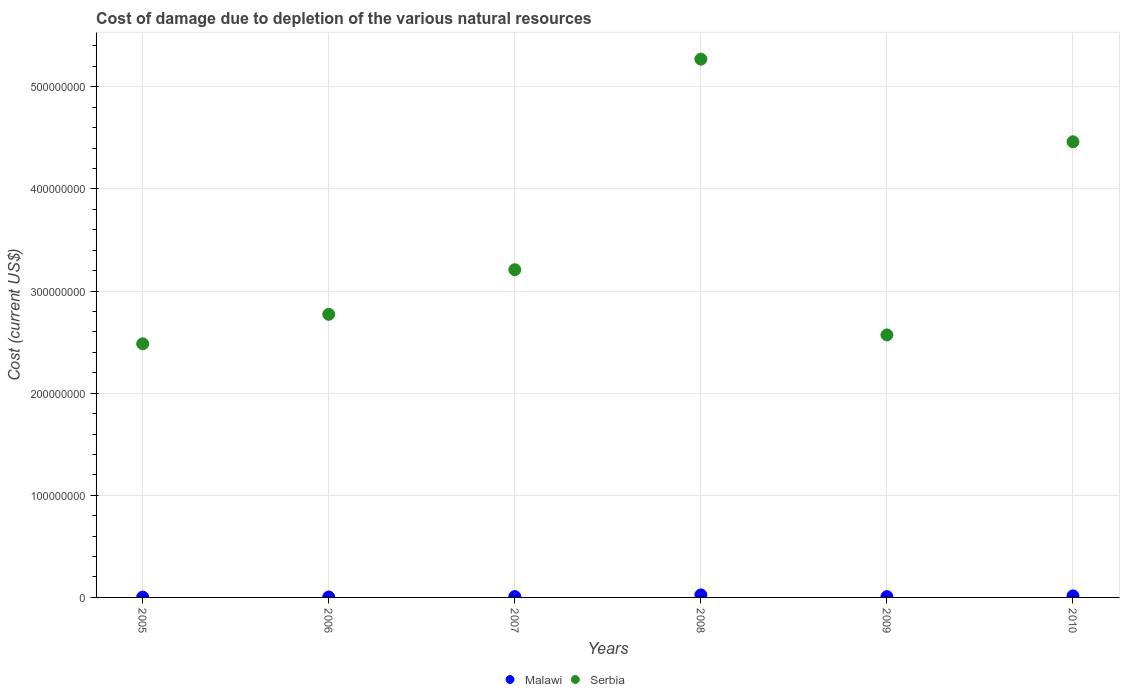Is the number of dotlines equal to the number of legend labels?
Keep it short and to the point. Yes. What is the cost of damage caused due to the depletion of various natural resources in Malawi in 2009?
Offer a terse response. 7.64e+05. Across all years, what is the maximum cost of damage caused due to the depletion of various natural resources in Malawi?
Make the answer very short. 2.45e+06. Across all years, what is the minimum cost of damage caused due to the depletion of various natural resources in Serbia?
Offer a terse response. 2.48e+08. In which year was the cost of damage caused due to the depletion of various natural resources in Serbia maximum?
Make the answer very short. 2008. What is the total cost of damage caused due to the depletion of various natural resources in Malawi in the graph?
Provide a succinct answer. 6.19e+06. What is the difference between the cost of damage caused due to the depletion of various natural resources in Malawi in 2006 and that in 2008?
Your answer should be very brief. -2.06e+06. What is the difference between the cost of damage caused due to the depletion of various natural resources in Malawi in 2005 and the cost of damage caused due to the depletion of various natural resources in Serbia in 2009?
Keep it short and to the point. -2.57e+08. What is the average cost of damage caused due to the depletion of various natural resources in Malawi per year?
Your response must be concise. 1.03e+06. In the year 2006, what is the difference between the cost of damage caused due to the depletion of various natural resources in Serbia and cost of damage caused due to the depletion of various natural resources in Malawi?
Make the answer very short. 2.77e+08. In how many years, is the cost of damage caused due to the depletion of various natural resources in Serbia greater than 440000000 US$?
Your answer should be compact. 2. What is the ratio of the cost of damage caused due to the depletion of various natural resources in Serbia in 2005 to that in 2008?
Your answer should be very brief. 0.47. Is the difference between the cost of damage caused due to the depletion of various natural resources in Serbia in 2008 and 2009 greater than the difference between the cost of damage caused due to the depletion of various natural resources in Malawi in 2008 and 2009?
Keep it short and to the point. Yes. What is the difference between the highest and the second highest cost of damage caused due to the depletion of various natural resources in Serbia?
Your answer should be compact. 8.09e+07. What is the difference between the highest and the lowest cost of damage caused due to the depletion of various natural resources in Serbia?
Your answer should be very brief. 2.79e+08. In how many years, is the cost of damage caused due to the depletion of various natural resources in Malawi greater than the average cost of damage caused due to the depletion of various natural resources in Malawi taken over all years?
Offer a terse response. 2. Is the sum of the cost of damage caused due to the depletion of various natural resources in Malawi in 2006 and 2009 greater than the maximum cost of damage caused due to the depletion of various natural resources in Serbia across all years?
Your response must be concise. No. Is the cost of damage caused due to the depletion of various natural resources in Serbia strictly greater than the cost of damage caused due to the depletion of various natural resources in Malawi over the years?
Ensure brevity in your answer.  Yes. Is the cost of damage caused due to the depletion of various natural resources in Malawi strictly less than the cost of damage caused due to the depletion of various natural resources in Serbia over the years?
Provide a succinct answer. Yes. What is the difference between two consecutive major ticks on the Y-axis?
Your response must be concise. 1.00e+08. Are the values on the major ticks of Y-axis written in scientific E-notation?
Your response must be concise. No. How many legend labels are there?
Provide a succinct answer. 2. What is the title of the graph?
Keep it short and to the point. Cost of damage due to depletion of the various natural resources. Does "Cote d'Ivoire" appear as one of the legend labels in the graph?
Offer a very short reply. No. What is the label or title of the Y-axis?
Your response must be concise. Cost (current US$). What is the Cost (current US$) of Malawi in 2005?
Keep it short and to the point. 2.70e+05. What is the Cost (current US$) in Serbia in 2005?
Offer a very short reply. 2.48e+08. What is the Cost (current US$) in Malawi in 2006?
Make the answer very short. 3.92e+05. What is the Cost (current US$) in Serbia in 2006?
Make the answer very short. 2.77e+08. What is the Cost (current US$) in Malawi in 2007?
Provide a succinct answer. 8.16e+05. What is the Cost (current US$) of Serbia in 2007?
Offer a terse response. 3.21e+08. What is the Cost (current US$) of Malawi in 2008?
Your response must be concise. 2.45e+06. What is the Cost (current US$) of Serbia in 2008?
Offer a very short reply. 5.27e+08. What is the Cost (current US$) in Malawi in 2009?
Offer a very short reply. 7.64e+05. What is the Cost (current US$) in Serbia in 2009?
Offer a terse response. 2.57e+08. What is the Cost (current US$) in Malawi in 2010?
Provide a succinct answer. 1.50e+06. What is the Cost (current US$) of Serbia in 2010?
Offer a terse response. 4.46e+08. Across all years, what is the maximum Cost (current US$) of Malawi?
Make the answer very short. 2.45e+06. Across all years, what is the maximum Cost (current US$) in Serbia?
Offer a very short reply. 5.27e+08. Across all years, what is the minimum Cost (current US$) of Malawi?
Provide a succinct answer. 2.70e+05. Across all years, what is the minimum Cost (current US$) in Serbia?
Your response must be concise. 2.48e+08. What is the total Cost (current US$) in Malawi in the graph?
Keep it short and to the point. 6.19e+06. What is the total Cost (current US$) in Serbia in the graph?
Ensure brevity in your answer.  2.08e+09. What is the difference between the Cost (current US$) of Malawi in 2005 and that in 2006?
Give a very brief answer. -1.23e+05. What is the difference between the Cost (current US$) in Serbia in 2005 and that in 2006?
Provide a short and direct response. -2.89e+07. What is the difference between the Cost (current US$) of Malawi in 2005 and that in 2007?
Keep it short and to the point. -5.46e+05. What is the difference between the Cost (current US$) of Serbia in 2005 and that in 2007?
Offer a very short reply. -7.25e+07. What is the difference between the Cost (current US$) in Malawi in 2005 and that in 2008?
Provide a short and direct response. -2.18e+06. What is the difference between the Cost (current US$) in Serbia in 2005 and that in 2008?
Offer a terse response. -2.79e+08. What is the difference between the Cost (current US$) of Malawi in 2005 and that in 2009?
Your answer should be very brief. -4.94e+05. What is the difference between the Cost (current US$) of Serbia in 2005 and that in 2009?
Provide a succinct answer. -8.68e+06. What is the difference between the Cost (current US$) of Malawi in 2005 and that in 2010?
Offer a terse response. -1.23e+06. What is the difference between the Cost (current US$) of Serbia in 2005 and that in 2010?
Give a very brief answer. -1.98e+08. What is the difference between the Cost (current US$) of Malawi in 2006 and that in 2007?
Your answer should be very brief. -4.23e+05. What is the difference between the Cost (current US$) in Serbia in 2006 and that in 2007?
Provide a short and direct response. -4.37e+07. What is the difference between the Cost (current US$) of Malawi in 2006 and that in 2008?
Offer a very short reply. -2.06e+06. What is the difference between the Cost (current US$) of Serbia in 2006 and that in 2008?
Offer a terse response. -2.50e+08. What is the difference between the Cost (current US$) of Malawi in 2006 and that in 2009?
Offer a very short reply. -3.72e+05. What is the difference between the Cost (current US$) in Serbia in 2006 and that in 2009?
Provide a succinct answer. 2.02e+07. What is the difference between the Cost (current US$) in Malawi in 2006 and that in 2010?
Keep it short and to the point. -1.10e+06. What is the difference between the Cost (current US$) of Serbia in 2006 and that in 2010?
Ensure brevity in your answer.  -1.69e+08. What is the difference between the Cost (current US$) in Malawi in 2007 and that in 2008?
Ensure brevity in your answer.  -1.63e+06. What is the difference between the Cost (current US$) of Serbia in 2007 and that in 2008?
Your answer should be compact. -2.06e+08. What is the difference between the Cost (current US$) of Malawi in 2007 and that in 2009?
Give a very brief answer. 5.16e+04. What is the difference between the Cost (current US$) in Serbia in 2007 and that in 2009?
Make the answer very short. 6.39e+07. What is the difference between the Cost (current US$) of Malawi in 2007 and that in 2010?
Provide a succinct answer. -6.81e+05. What is the difference between the Cost (current US$) of Serbia in 2007 and that in 2010?
Your response must be concise. -1.25e+08. What is the difference between the Cost (current US$) in Malawi in 2008 and that in 2009?
Offer a terse response. 1.69e+06. What is the difference between the Cost (current US$) in Serbia in 2008 and that in 2009?
Your answer should be compact. 2.70e+08. What is the difference between the Cost (current US$) in Malawi in 2008 and that in 2010?
Your answer should be very brief. 9.53e+05. What is the difference between the Cost (current US$) of Serbia in 2008 and that in 2010?
Make the answer very short. 8.09e+07. What is the difference between the Cost (current US$) of Malawi in 2009 and that in 2010?
Ensure brevity in your answer.  -7.32e+05. What is the difference between the Cost (current US$) of Serbia in 2009 and that in 2010?
Provide a succinct answer. -1.89e+08. What is the difference between the Cost (current US$) of Malawi in 2005 and the Cost (current US$) of Serbia in 2006?
Keep it short and to the point. -2.77e+08. What is the difference between the Cost (current US$) of Malawi in 2005 and the Cost (current US$) of Serbia in 2007?
Ensure brevity in your answer.  -3.21e+08. What is the difference between the Cost (current US$) of Malawi in 2005 and the Cost (current US$) of Serbia in 2008?
Provide a short and direct response. -5.27e+08. What is the difference between the Cost (current US$) of Malawi in 2005 and the Cost (current US$) of Serbia in 2009?
Your answer should be very brief. -2.57e+08. What is the difference between the Cost (current US$) in Malawi in 2005 and the Cost (current US$) in Serbia in 2010?
Provide a short and direct response. -4.46e+08. What is the difference between the Cost (current US$) of Malawi in 2006 and the Cost (current US$) of Serbia in 2007?
Your answer should be very brief. -3.20e+08. What is the difference between the Cost (current US$) of Malawi in 2006 and the Cost (current US$) of Serbia in 2008?
Offer a very short reply. -5.27e+08. What is the difference between the Cost (current US$) of Malawi in 2006 and the Cost (current US$) of Serbia in 2009?
Your answer should be very brief. -2.57e+08. What is the difference between the Cost (current US$) of Malawi in 2006 and the Cost (current US$) of Serbia in 2010?
Offer a terse response. -4.46e+08. What is the difference between the Cost (current US$) of Malawi in 2007 and the Cost (current US$) of Serbia in 2008?
Keep it short and to the point. -5.26e+08. What is the difference between the Cost (current US$) in Malawi in 2007 and the Cost (current US$) in Serbia in 2009?
Your answer should be compact. -2.56e+08. What is the difference between the Cost (current US$) in Malawi in 2007 and the Cost (current US$) in Serbia in 2010?
Offer a very short reply. -4.45e+08. What is the difference between the Cost (current US$) of Malawi in 2008 and the Cost (current US$) of Serbia in 2009?
Ensure brevity in your answer.  -2.55e+08. What is the difference between the Cost (current US$) in Malawi in 2008 and the Cost (current US$) in Serbia in 2010?
Your answer should be compact. -4.44e+08. What is the difference between the Cost (current US$) in Malawi in 2009 and the Cost (current US$) in Serbia in 2010?
Offer a very short reply. -4.45e+08. What is the average Cost (current US$) of Malawi per year?
Your answer should be very brief. 1.03e+06. What is the average Cost (current US$) in Serbia per year?
Keep it short and to the point. 3.46e+08. In the year 2005, what is the difference between the Cost (current US$) of Malawi and Cost (current US$) of Serbia?
Provide a succinct answer. -2.48e+08. In the year 2006, what is the difference between the Cost (current US$) of Malawi and Cost (current US$) of Serbia?
Keep it short and to the point. -2.77e+08. In the year 2007, what is the difference between the Cost (current US$) of Malawi and Cost (current US$) of Serbia?
Offer a terse response. -3.20e+08. In the year 2008, what is the difference between the Cost (current US$) in Malawi and Cost (current US$) in Serbia?
Give a very brief answer. -5.25e+08. In the year 2009, what is the difference between the Cost (current US$) of Malawi and Cost (current US$) of Serbia?
Your answer should be very brief. -2.56e+08. In the year 2010, what is the difference between the Cost (current US$) of Malawi and Cost (current US$) of Serbia?
Make the answer very short. -4.45e+08. What is the ratio of the Cost (current US$) in Malawi in 2005 to that in 2006?
Offer a terse response. 0.69. What is the ratio of the Cost (current US$) of Serbia in 2005 to that in 2006?
Your answer should be very brief. 0.9. What is the ratio of the Cost (current US$) in Malawi in 2005 to that in 2007?
Provide a succinct answer. 0.33. What is the ratio of the Cost (current US$) in Serbia in 2005 to that in 2007?
Offer a very short reply. 0.77. What is the ratio of the Cost (current US$) in Malawi in 2005 to that in 2008?
Offer a very short reply. 0.11. What is the ratio of the Cost (current US$) of Serbia in 2005 to that in 2008?
Ensure brevity in your answer.  0.47. What is the ratio of the Cost (current US$) of Malawi in 2005 to that in 2009?
Ensure brevity in your answer.  0.35. What is the ratio of the Cost (current US$) in Serbia in 2005 to that in 2009?
Give a very brief answer. 0.97. What is the ratio of the Cost (current US$) in Malawi in 2005 to that in 2010?
Your response must be concise. 0.18. What is the ratio of the Cost (current US$) of Serbia in 2005 to that in 2010?
Offer a terse response. 0.56. What is the ratio of the Cost (current US$) in Malawi in 2006 to that in 2007?
Your answer should be compact. 0.48. What is the ratio of the Cost (current US$) in Serbia in 2006 to that in 2007?
Your answer should be compact. 0.86. What is the ratio of the Cost (current US$) in Malawi in 2006 to that in 2008?
Your answer should be compact. 0.16. What is the ratio of the Cost (current US$) in Serbia in 2006 to that in 2008?
Your answer should be compact. 0.53. What is the ratio of the Cost (current US$) in Malawi in 2006 to that in 2009?
Provide a succinct answer. 0.51. What is the ratio of the Cost (current US$) in Serbia in 2006 to that in 2009?
Offer a very short reply. 1.08. What is the ratio of the Cost (current US$) of Malawi in 2006 to that in 2010?
Give a very brief answer. 0.26. What is the ratio of the Cost (current US$) in Serbia in 2006 to that in 2010?
Offer a very short reply. 0.62. What is the ratio of the Cost (current US$) in Malawi in 2007 to that in 2008?
Provide a short and direct response. 0.33. What is the ratio of the Cost (current US$) in Serbia in 2007 to that in 2008?
Ensure brevity in your answer.  0.61. What is the ratio of the Cost (current US$) of Malawi in 2007 to that in 2009?
Your answer should be compact. 1.07. What is the ratio of the Cost (current US$) in Serbia in 2007 to that in 2009?
Provide a succinct answer. 1.25. What is the ratio of the Cost (current US$) of Malawi in 2007 to that in 2010?
Your response must be concise. 0.55. What is the ratio of the Cost (current US$) in Serbia in 2007 to that in 2010?
Offer a terse response. 0.72. What is the ratio of the Cost (current US$) in Malawi in 2008 to that in 2009?
Ensure brevity in your answer.  3.21. What is the ratio of the Cost (current US$) in Serbia in 2008 to that in 2009?
Make the answer very short. 2.05. What is the ratio of the Cost (current US$) in Malawi in 2008 to that in 2010?
Give a very brief answer. 1.64. What is the ratio of the Cost (current US$) of Serbia in 2008 to that in 2010?
Keep it short and to the point. 1.18. What is the ratio of the Cost (current US$) of Malawi in 2009 to that in 2010?
Your answer should be compact. 0.51. What is the ratio of the Cost (current US$) of Serbia in 2009 to that in 2010?
Offer a terse response. 0.58. What is the difference between the highest and the second highest Cost (current US$) in Malawi?
Offer a terse response. 9.53e+05. What is the difference between the highest and the second highest Cost (current US$) in Serbia?
Make the answer very short. 8.09e+07. What is the difference between the highest and the lowest Cost (current US$) of Malawi?
Keep it short and to the point. 2.18e+06. What is the difference between the highest and the lowest Cost (current US$) of Serbia?
Give a very brief answer. 2.79e+08. 